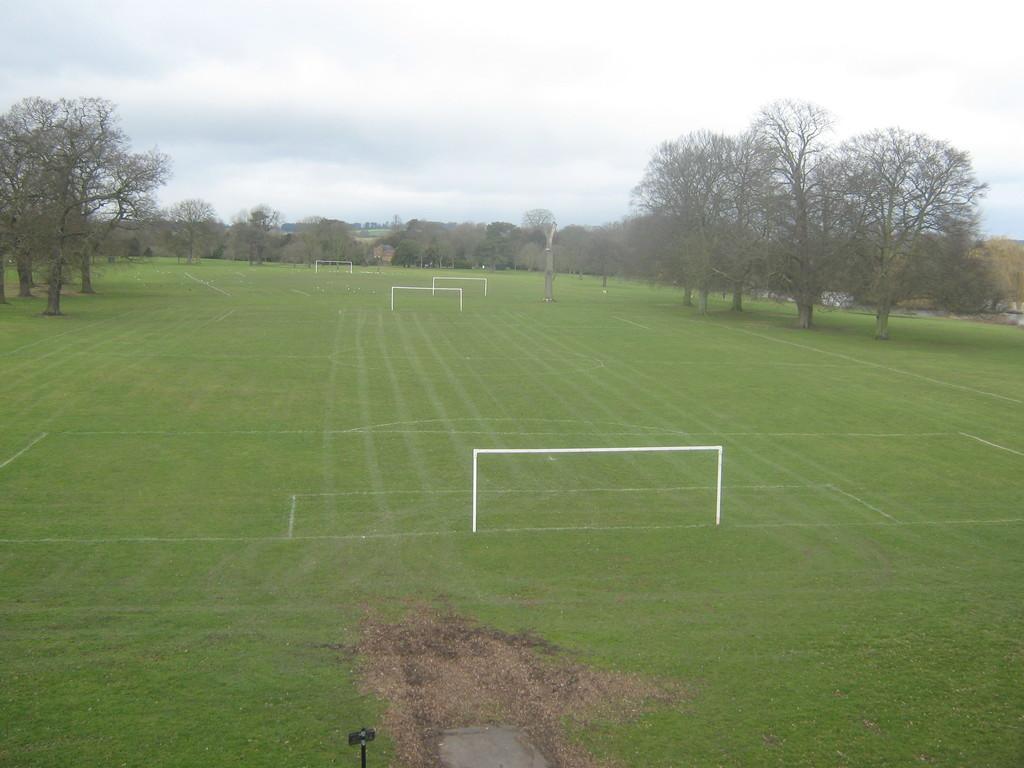How would you summarize this image in a sentence or two? In this image we can see there are two football grounds and there are many trees in the background. 